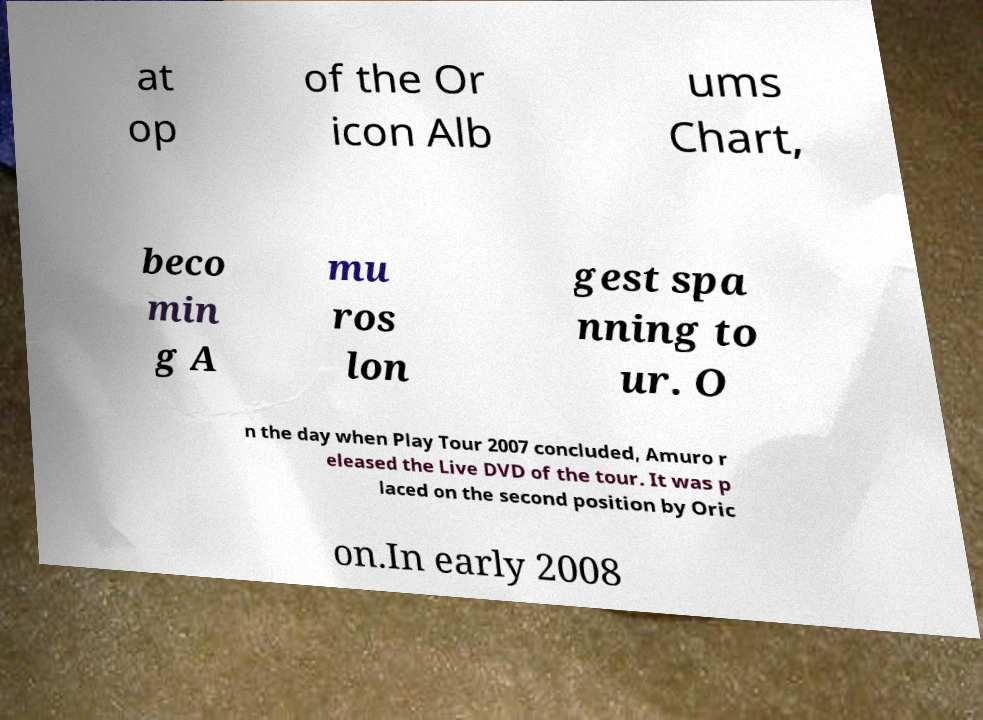Please read and relay the text visible in this image. What does it say? at op of the Or icon Alb ums Chart, beco min g A mu ros lon gest spa nning to ur. O n the day when Play Tour 2007 concluded, Amuro r eleased the Live DVD of the tour. It was p laced on the second position by Oric on.In early 2008 